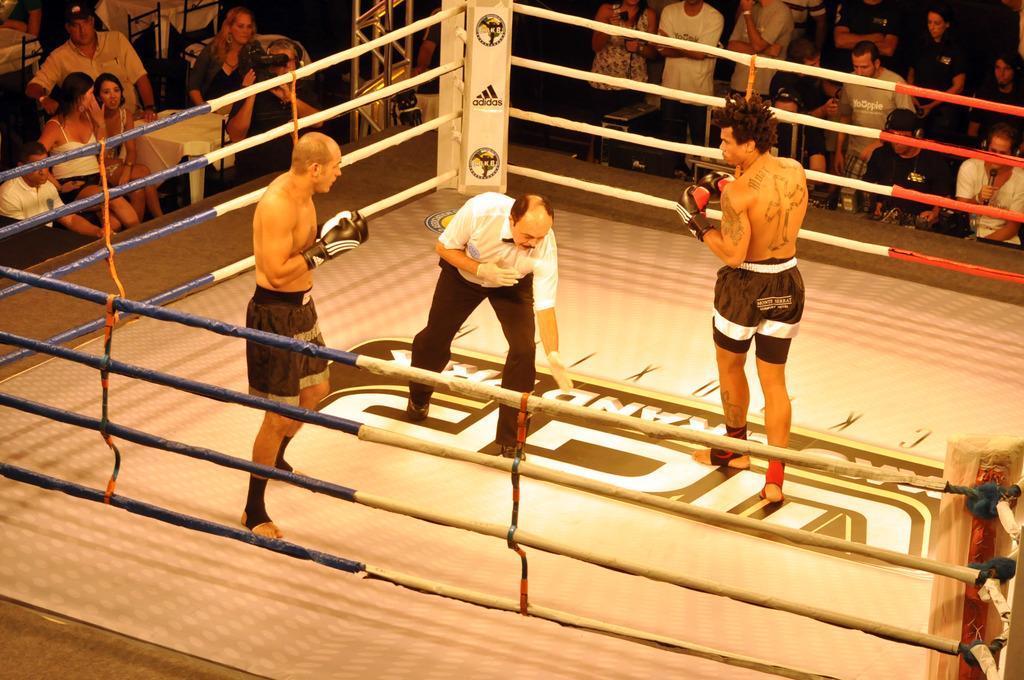In one or two sentences, can you explain what this image depicts? This image consists of two persons in a ring. They are wearing black shorts. In the middle, there is a person wearing a white T-shirt and a pant. In the background, there are many people. 